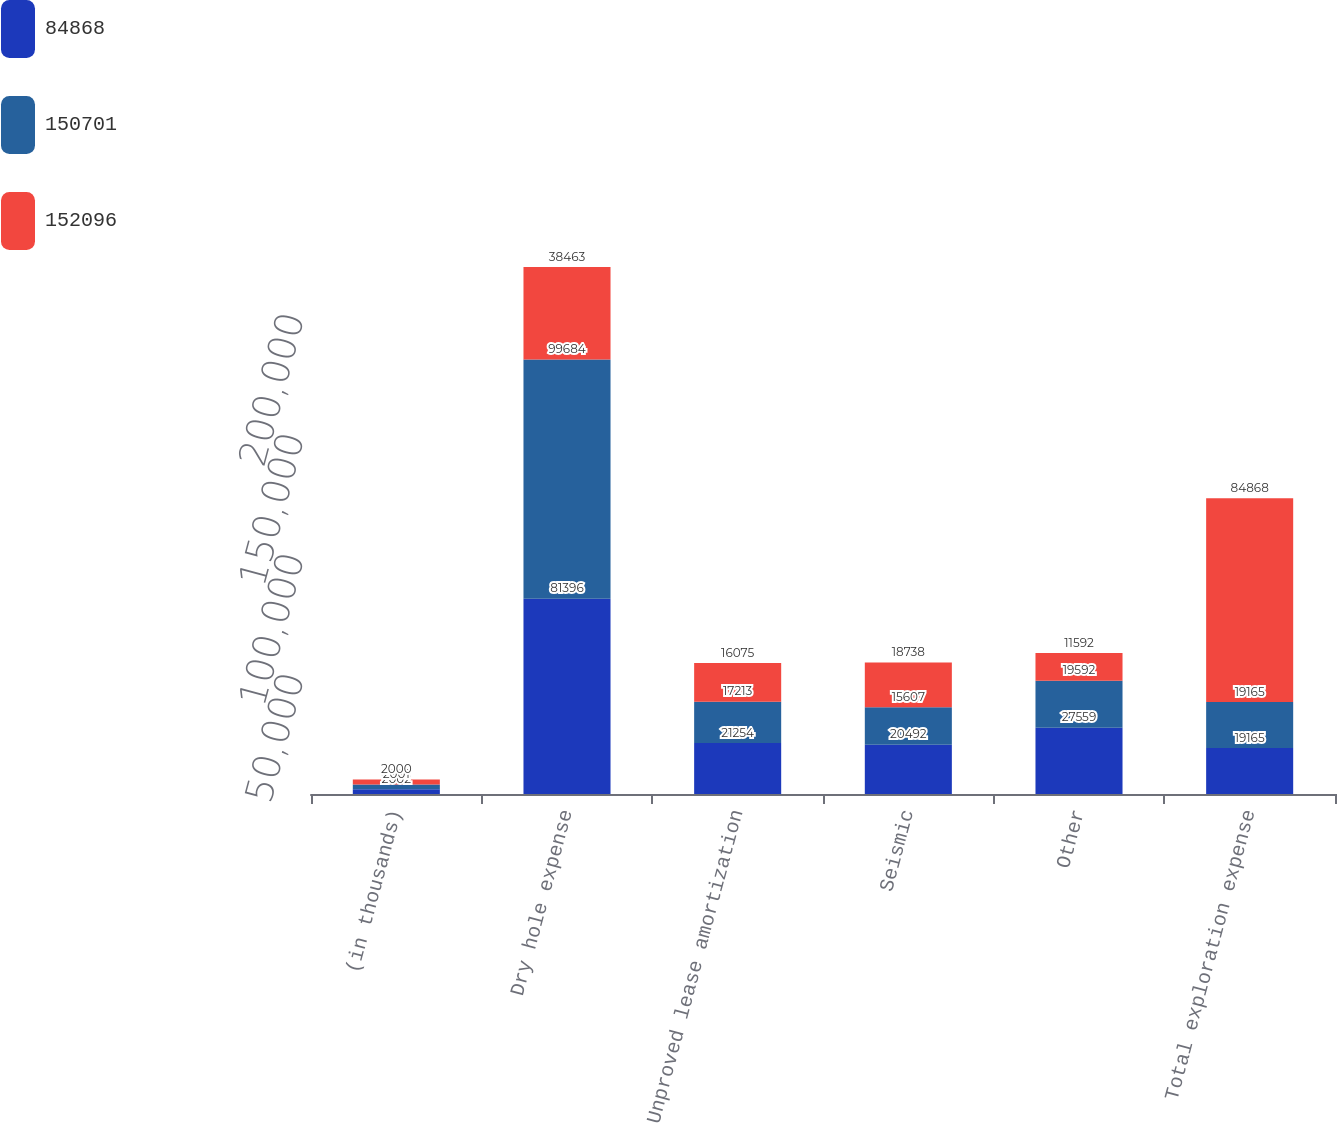Convert chart to OTSL. <chart><loc_0><loc_0><loc_500><loc_500><stacked_bar_chart><ecel><fcel>(in thousands)<fcel>Dry hole expense<fcel>Unproved lease amortization<fcel>Seismic<fcel>Other<fcel>Total exploration expense<nl><fcel>84868<fcel>2002<fcel>81396<fcel>21254<fcel>20492<fcel>27559<fcel>19165<nl><fcel>150701<fcel>2001<fcel>99684<fcel>17213<fcel>15607<fcel>19592<fcel>19165<nl><fcel>152096<fcel>2000<fcel>38463<fcel>16075<fcel>18738<fcel>11592<fcel>84868<nl></chart> 